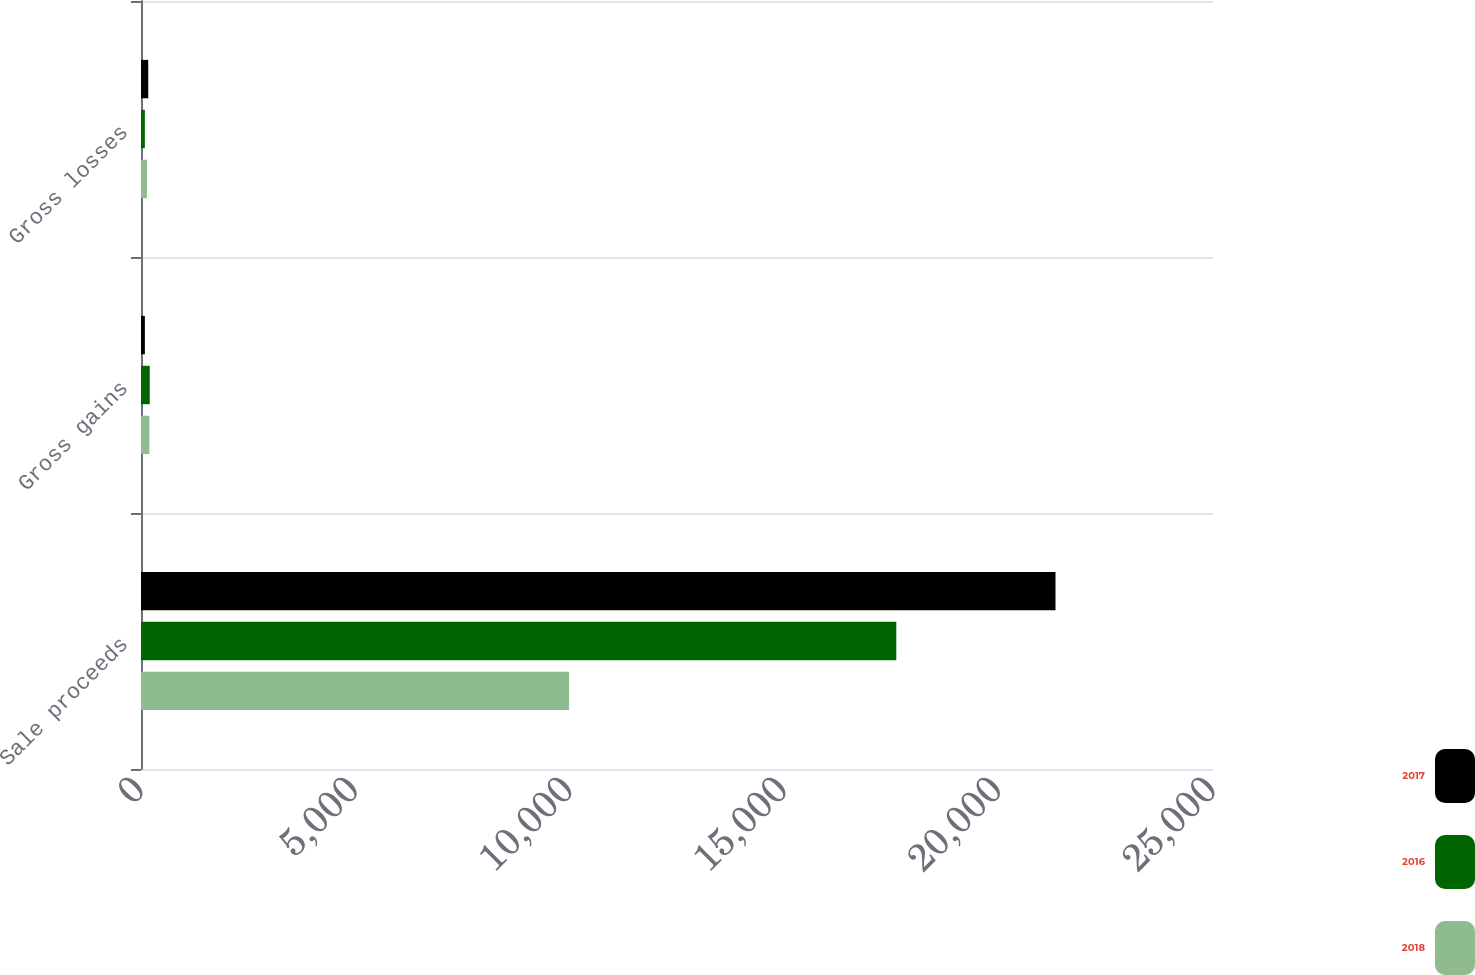Convert chart to OTSL. <chart><loc_0><loc_0><loc_500><loc_500><stacked_bar_chart><ecel><fcel>Sale proceeds<fcel>Gross gains<fcel>Gross losses<nl><fcel>2017<fcel>21327<fcel>90<fcel>169<nl><fcel>2016<fcel>17614<fcel>204<fcel>90<nl><fcel>2018<fcel>9984<fcel>196<fcel>138<nl></chart> 